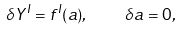<formula> <loc_0><loc_0><loc_500><loc_500>\delta Y ^ { I } = f ^ { I } ( a ) , \quad \delta a = 0 ,</formula> 